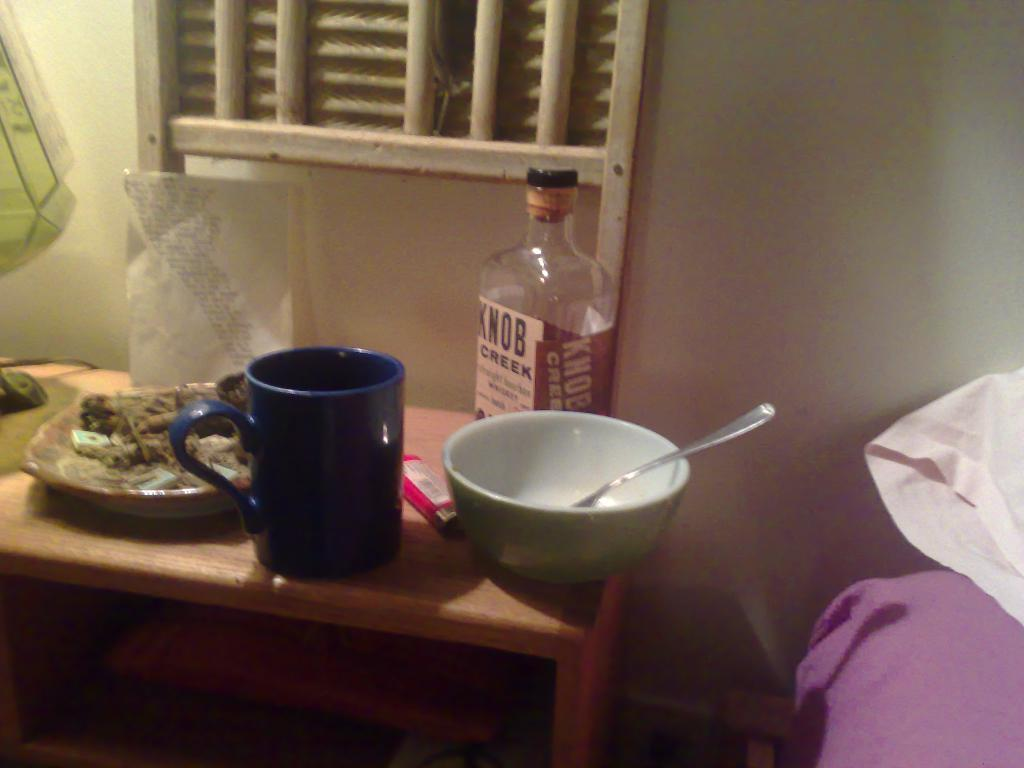<image>
Render a clear and concise summary of the photo. A bottle of Knob Creek sits behind a bowl. 